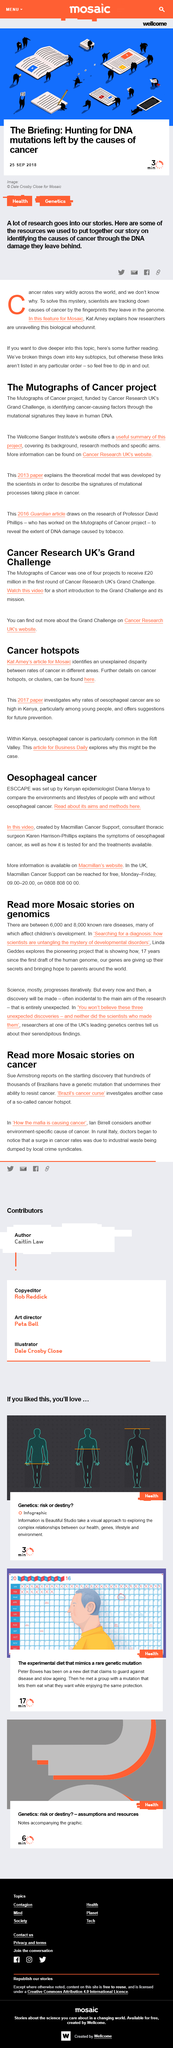Mention a couple of crucial points in this snapshot. In the article by Kate Amey published in Mosaic, an unexplained disparity between rates of cancer in different areas was identified. In the geographical area of Kenya known as the Rift Valley, oesophageal cancer is particularly prevalent. It is not Diana Menya who discusses the symptoms of oesophageal cancer, but rather Dr. Karen Harrison-Phillips. Scientists are actively searching for the causes of cancer by analyzing the genetic fingerprints left behind by the disease. The Mutographs of Cancer project is identifying cancer-causing factors by analyzing mutational signatures left in human DNA. 